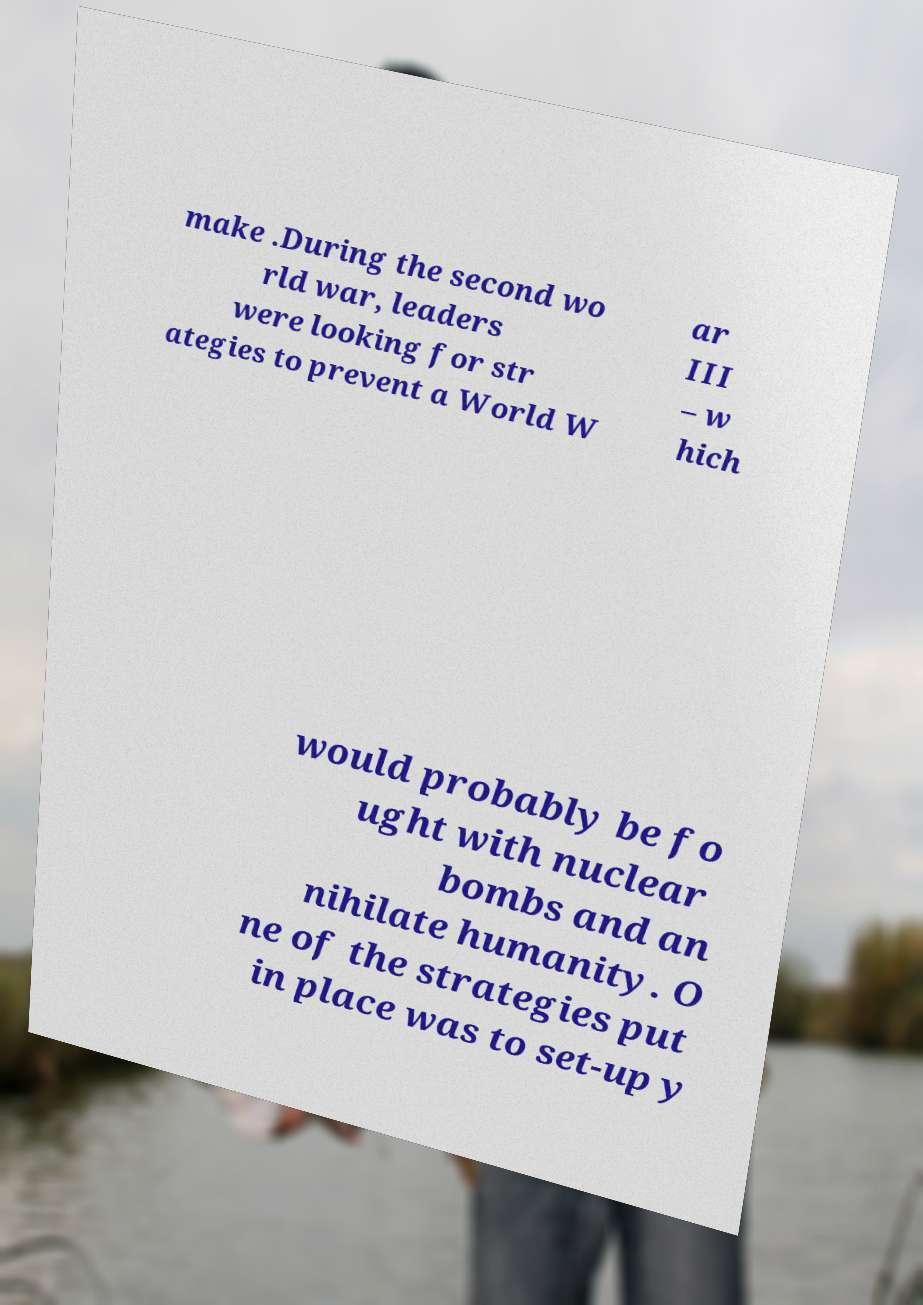For documentation purposes, I need the text within this image transcribed. Could you provide that? make .During the second wo rld war, leaders were looking for str ategies to prevent a World W ar III – w hich would probably be fo ught with nuclear bombs and an nihilate humanity. O ne of the strategies put in place was to set-up y 